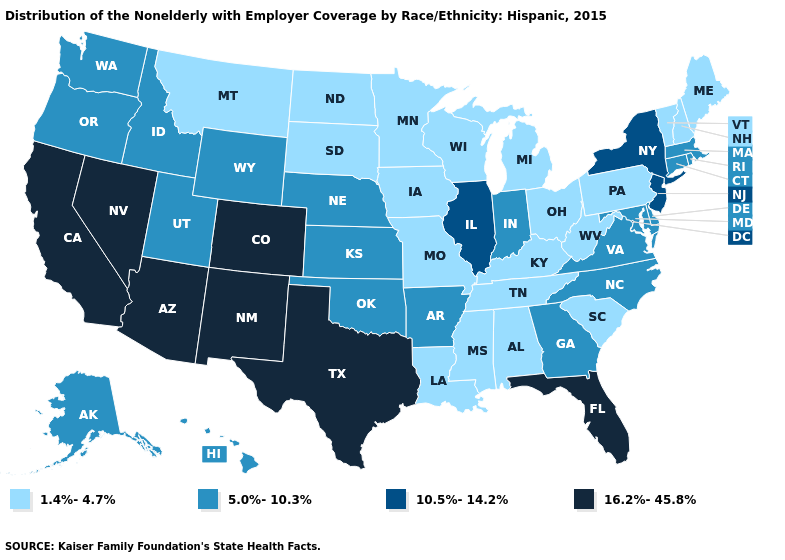Among the states that border Illinois , does Indiana have the highest value?
Quick response, please. Yes. Does North Carolina have the same value as Alaska?
Quick response, please. Yes. Name the states that have a value in the range 5.0%-10.3%?
Answer briefly. Alaska, Arkansas, Connecticut, Delaware, Georgia, Hawaii, Idaho, Indiana, Kansas, Maryland, Massachusetts, Nebraska, North Carolina, Oklahoma, Oregon, Rhode Island, Utah, Virginia, Washington, Wyoming. Name the states that have a value in the range 16.2%-45.8%?
Concise answer only. Arizona, California, Colorado, Florida, Nevada, New Mexico, Texas. Among the states that border Maryland , which have the lowest value?
Short answer required. Pennsylvania, West Virginia. Is the legend a continuous bar?
Keep it brief. No. Does the map have missing data?
Write a very short answer. No. Name the states that have a value in the range 1.4%-4.7%?
Keep it brief. Alabama, Iowa, Kentucky, Louisiana, Maine, Michigan, Minnesota, Mississippi, Missouri, Montana, New Hampshire, North Dakota, Ohio, Pennsylvania, South Carolina, South Dakota, Tennessee, Vermont, West Virginia, Wisconsin. Name the states that have a value in the range 5.0%-10.3%?
Short answer required. Alaska, Arkansas, Connecticut, Delaware, Georgia, Hawaii, Idaho, Indiana, Kansas, Maryland, Massachusetts, Nebraska, North Carolina, Oklahoma, Oregon, Rhode Island, Utah, Virginia, Washington, Wyoming. What is the value of Washington?
Keep it brief. 5.0%-10.3%. What is the highest value in states that border New Hampshire?
Write a very short answer. 5.0%-10.3%. What is the value of Georgia?
Keep it brief. 5.0%-10.3%. Name the states that have a value in the range 1.4%-4.7%?
Keep it brief. Alabama, Iowa, Kentucky, Louisiana, Maine, Michigan, Minnesota, Mississippi, Missouri, Montana, New Hampshire, North Dakota, Ohio, Pennsylvania, South Carolina, South Dakota, Tennessee, Vermont, West Virginia, Wisconsin. Among the states that border Georgia , which have the highest value?
Write a very short answer. Florida. What is the value of North Carolina?
Write a very short answer. 5.0%-10.3%. 